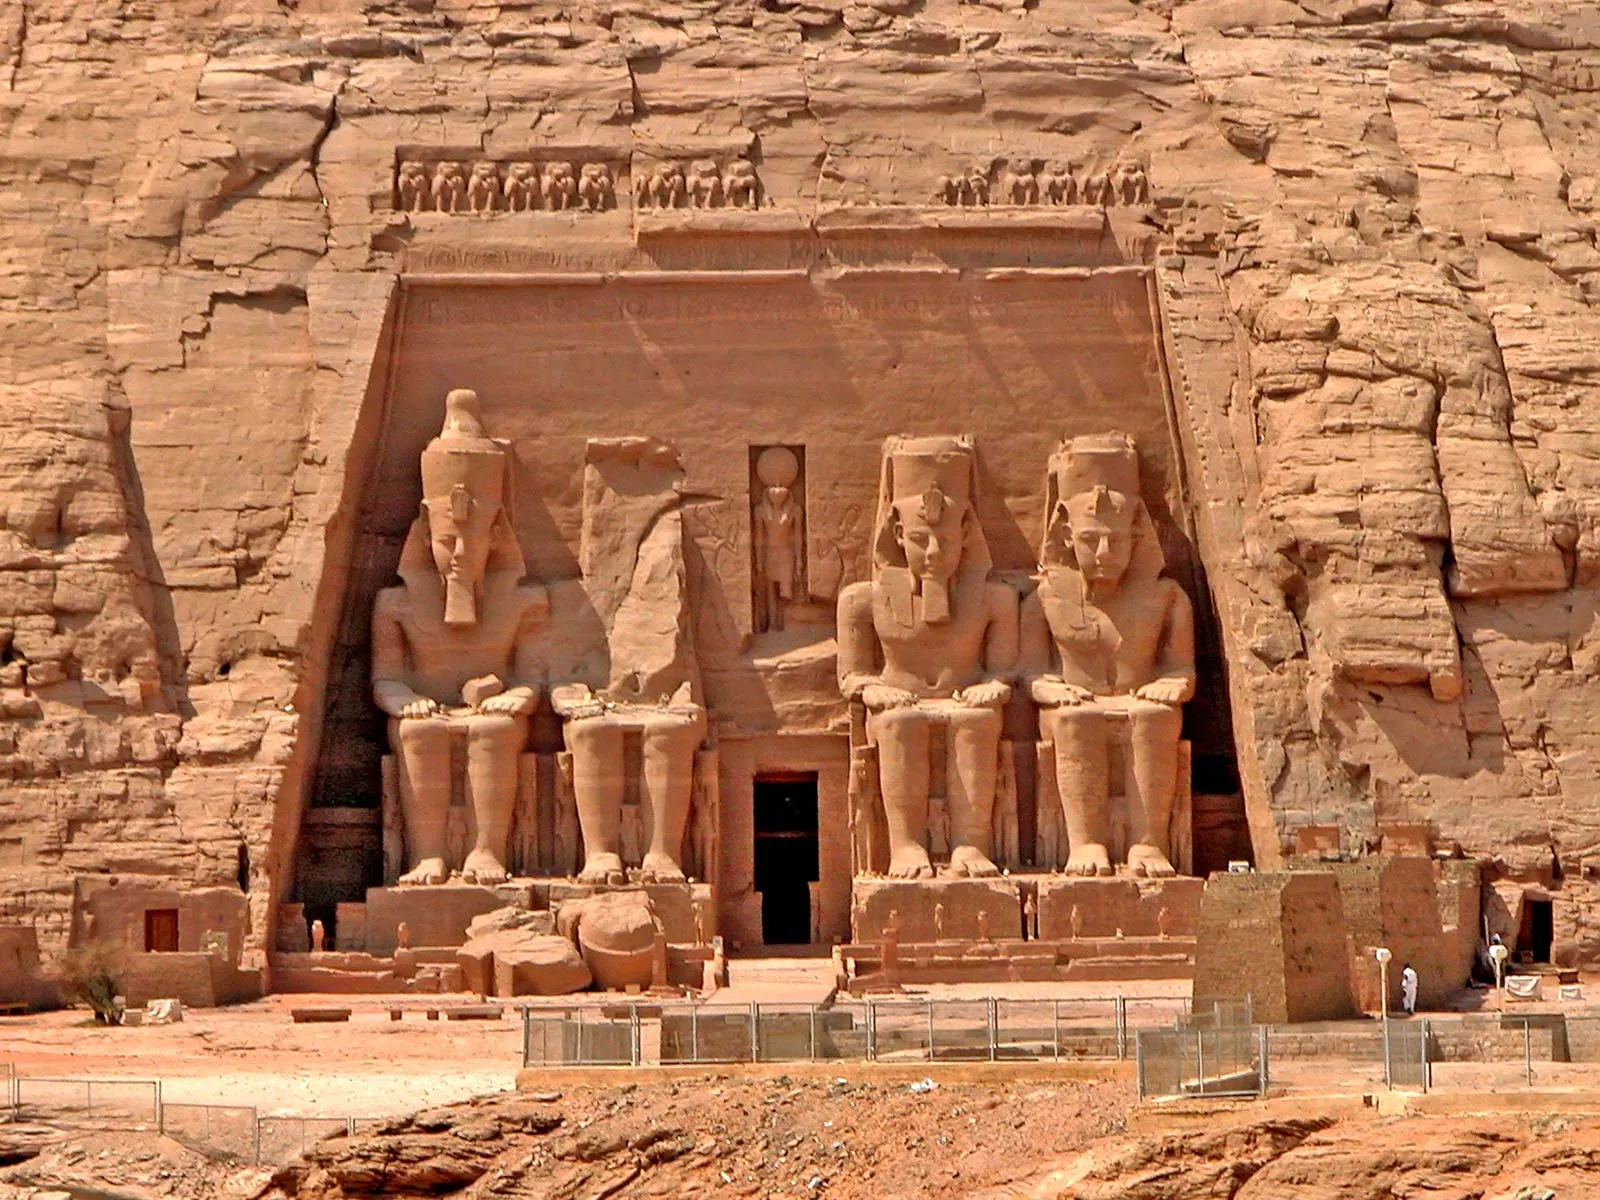What specific details can we observe about the statues at the Abu Simbel temple? The statues depicted in the image are colossal figures of the pharaoh Ramesses II, each about 20 meters tall. They are seated on thrones and wear the double crown of Upper and Lower Egypt, symbolizing Ramesses' rule over the unified kingdom. Intricate carvings are visible on their headdresses and the thrones, depicting various symbolic motifs and hieroglyphs. One can also observe smaller statues of family members, including statues of Queen Nefertari and the pharaoh's children, positioned around the legs of the larger statues. These details highlight the reverence and divine status attributed to Ramesses II and his lineage. Additionally, inscriptions and reliefs behind the statues narrate significant events from the pharaoh’s reign, offering insight into the history and culture of ancient Egypt. 